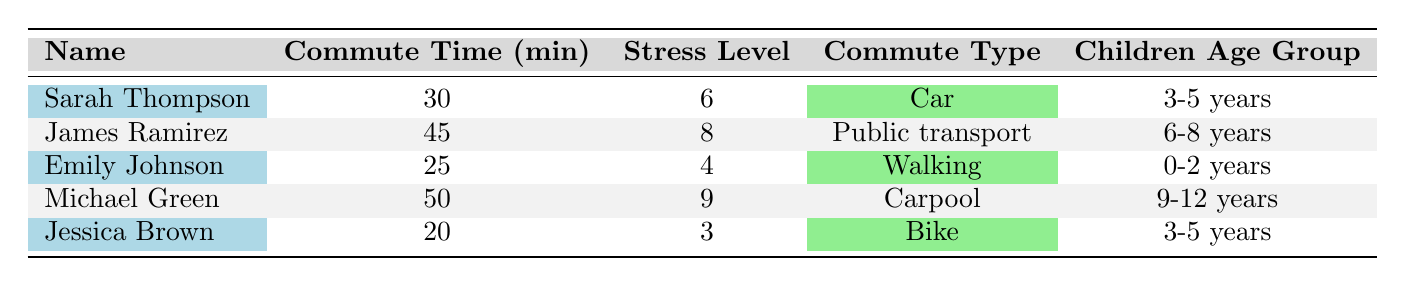What is the average commute time for all parents in the table? To find the average commute time, we first sum up the individual commute times: 30 + 45 + 25 + 50 + 20 = 170 minutes. There are 5 parents, so we divide the total by 5, giving us an average of 170/5 = 34 minutes.
Answer: 34 minutes Which parent has the highest stress level? By looking through the stress levels of all the parents, we see that Michael Green has a stress level of 9, which is the highest among all listed parents.
Answer: Michael Green How many parents commute by car? We check the "Commute Type" column and find that Sarah Thompson and Michael Green commute by car. Therefore, there are 2 parents that commute by car.
Answer: 2 parents Is there a parent with a stress level of 3? Looking at the stress levels from the table, we see that Jessica Brown has a stress level of 3, confirming that there is indeed a parent with this level of stress.
Answer: Yes What is the difference in average commute time between parents who bike and those who use public transport? Jessica Brown, who bikes, has an average commute time of 20 minutes, while James Ramirez, who uses public transport, has an average commute time of 45 minutes. The difference is calculated as 45 - 20 = 25 minutes.
Answer: 25 minutes Which commute type has the highest average stress level? To find this, we calculate the average stress levels for each commute type: Car (Sarah 6, Michael 9) = (6+9)/2 = 7.5; Public Transport (James 8) = 8; Walking (Emily 4) = 4; Carpool (Michael 9) = 9; Bike (Jessica 3) = 3. The highest average is Car (7.5) and Public Transport (8), thus Public Transport has the highest.
Answer: Public Transport Which parent has the shortest commute time and what is that time? Looking through the commute times, we find that Jessica Brown has the shortest commute time of 20 minutes.
Answer: Jessica Brown, 20 minutes Is the stress level of Sarah Thompson lower than that of Emily Johnson? Comparing the stress levels, Sarah Thompson has a stress level of 6 while Emily Johnson has 4. Since 6 is greater than 4, Sarah's stress level is not lower than Emily's.
Answer: No 